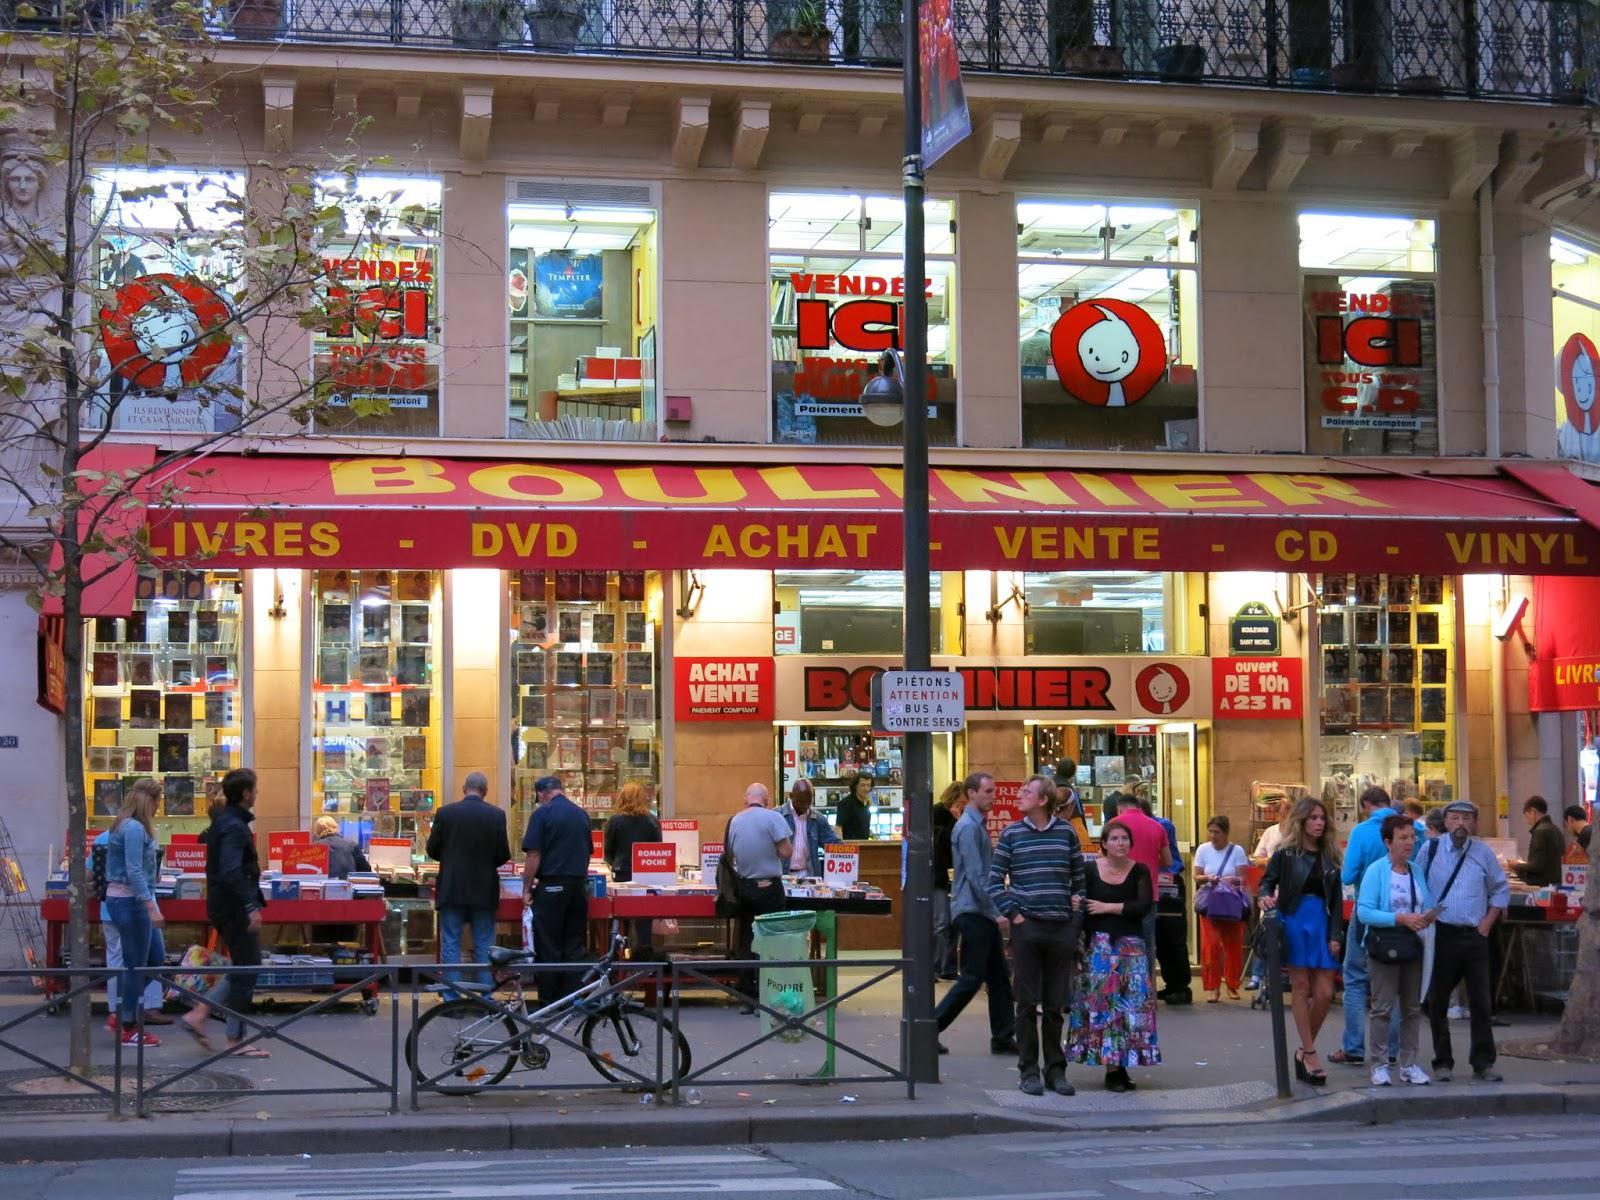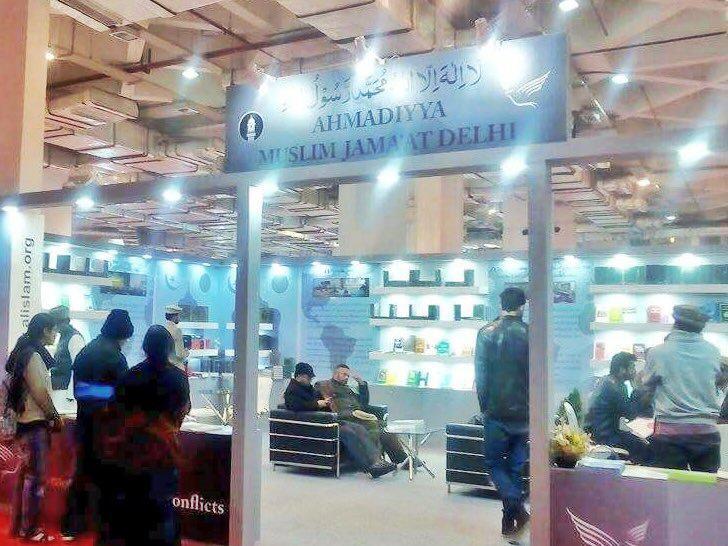The first image is the image on the left, the second image is the image on the right. Assess this claim about the two images: "There are no more than 3 people at the book store.". Correct or not? Answer yes or no. No. The first image is the image on the left, the second image is the image on the right. For the images shown, is this caption "One image shows a man in a light colored button up shirt sitting outside the store front next to piles of books." true? Answer yes or no. No. 